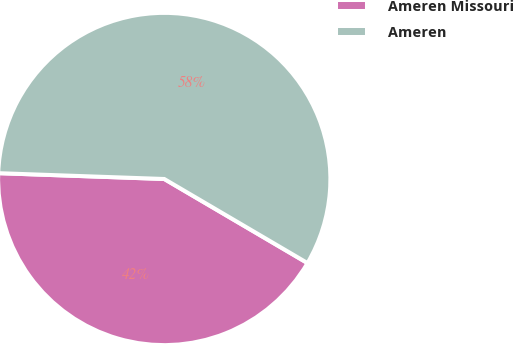Convert chart. <chart><loc_0><loc_0><loc_500><loc_500><pie_chart><fcel>Ameren Missouri<fcel>Ameren<nl><fcel>42.11%<fcel>57.89%<nl></chart> 